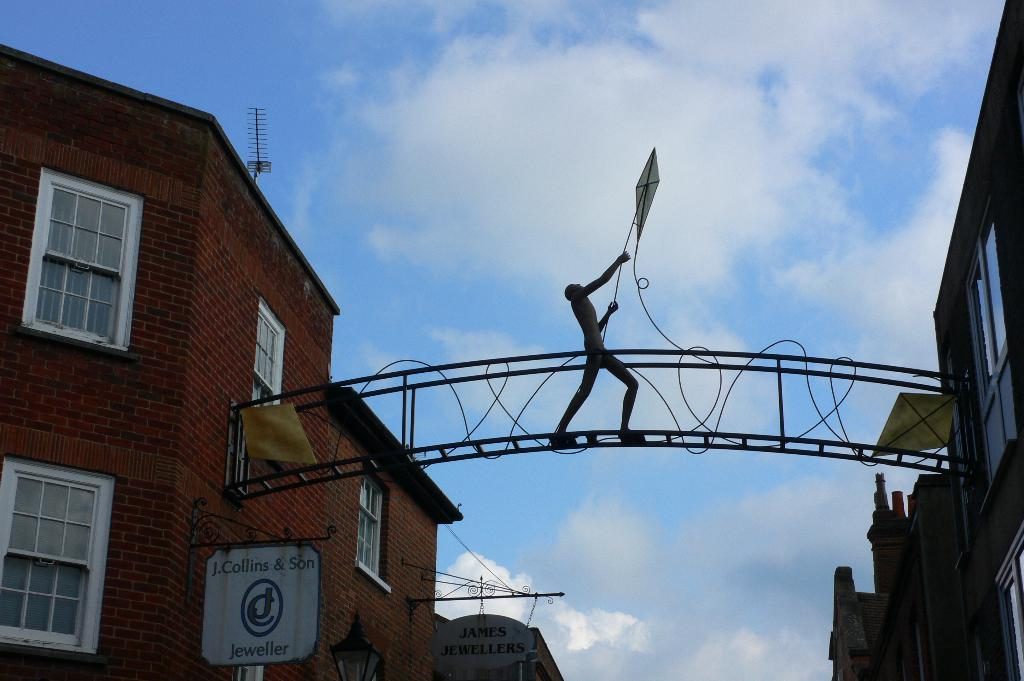What type of structure can be seen in the image? There is an arch in the image. What other objects are present in the image? There are boards, light poles, brick buildings, and an antenna in the image. What can be seen in the background of the image? The sky with clouds is visible in the background of the image. How many snails can be seen climbing on the antenna in the image? There are no snails present in the image, so it is not possible to determine how many might be climbing on the antenna. 